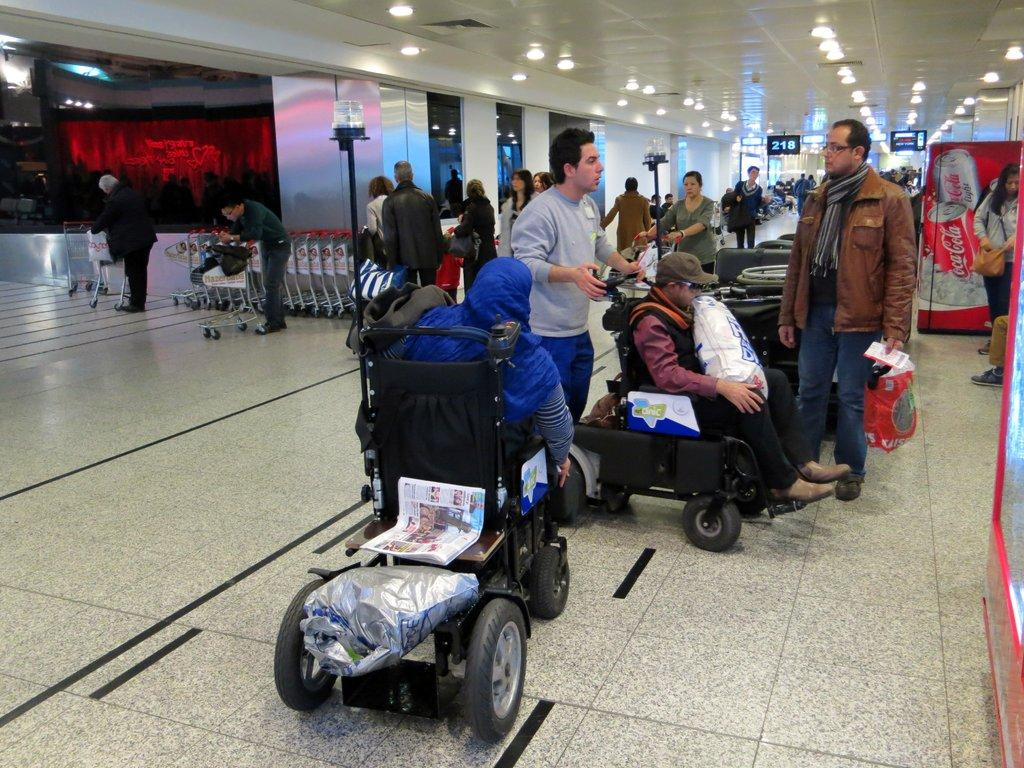<image>
Write a terse but informative summary of the picture. A group of people are at an airport and a Coca-Cola machine is visible in the background. 